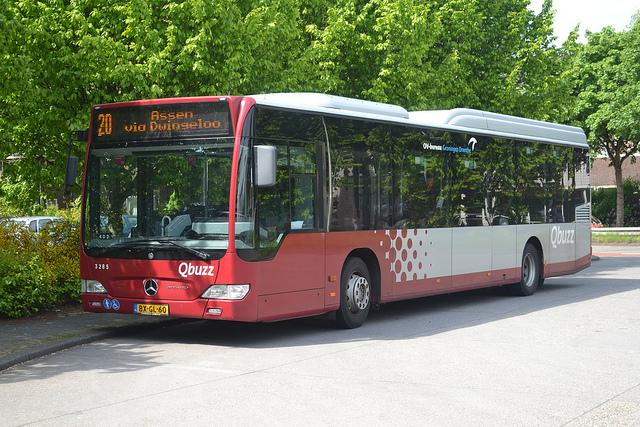What group of people are accommodated in this bus?

Choices:
A) handicapped
B) elderly
C) blind
D) pregnant women handicapped 